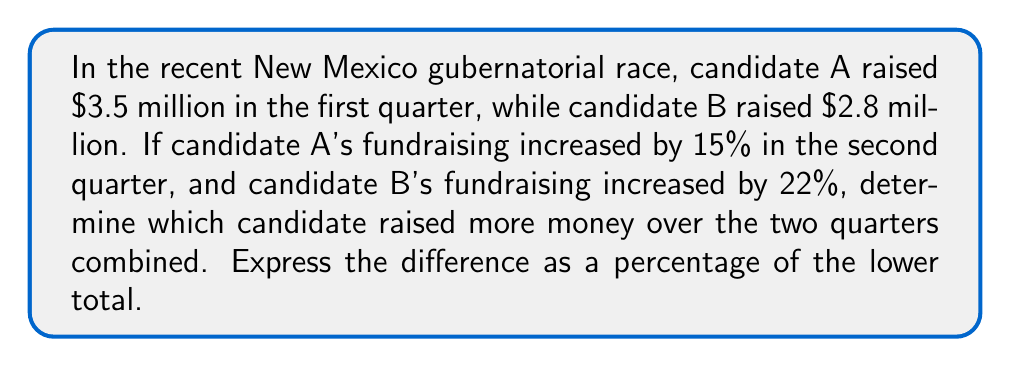Provide a solution to this math problem. Let's approach this step-by-step:

1) First, calculate candidate A's total fundraising:
   First quarter: $3.5 million
   Second quarter: $3.5 million × (1 + 0.15) = $3.5 million × 1.15 = $4.025 million
   Total for A: $3.5 million + $4.025 million = $7.525 million

2) Now, calculate candidate B's total fundraising:
   First quarter: $2.8 million
   Second quarter: $2.8 million × (1 + 0.22) = $2.8 million × 1.22 = $3.416 million
   Total for B: $2.8 million + $3.416 million = $6.216 million

3) Compare the totals:
   Candidate A: $7.525 million
   Candidate B: $6.216 million
   Candidate A raised more money.

4) Calculate the difference:
   $7.525 million - $6.216 million = $1.309 million

5) Express this difference as a percentage of the lower total:
   Percentage = $\frac{\text{Difference}}{\text{Lower Total}} \times 100\%$
   $= \frac{1.309}{6.216} \times 100\% \approx 21.06\%$
Answer: Candidate A raised more money over the two quarters combined. The difference is approximately 21.06% of candidate B's total. 